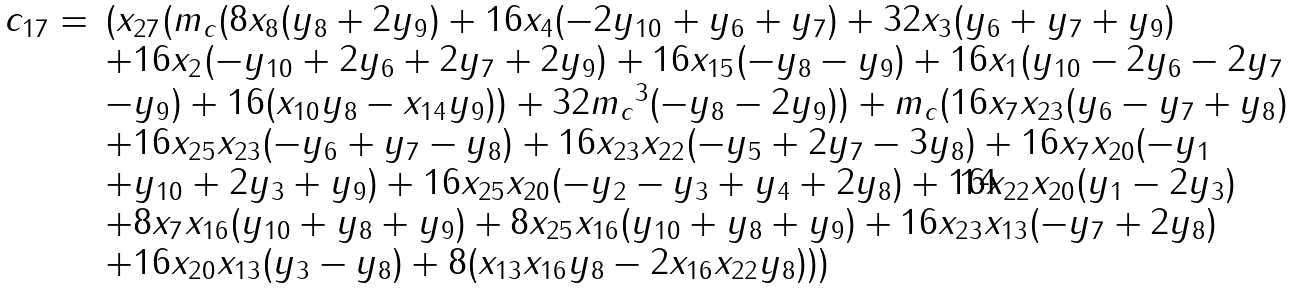Convert formula to latex. <formula><loc_0><loc_0><loc_500><loc_500>\begin{array} { l l } c _ { 1 7 } = & ( x _ { 2 7 } ( { m _ { c } } ( 8 x _ { 8 } ( y _ { 8 } + 2 y _ { 9 } ) + 1 6 x _ { 4 } ( - 2 y _ { 1 0 } + y _ { 6 } + y _ { 7 } ) + 3 2 x _ { 3 } ( y _ { 6 } + y _ { 7 } + y _ { 9 } ) \\ & + 1 6 x _ { 2 } ( - y _ { 1 0 } + 2 y _ { 6 } + 2 y _ { 7 } + 2 y _ { 9 } ) + 1 6 x _ { 1 5 } ( - y _ { 8 } - y _ { 9 } ) + 1 6 x _ { 1 } ( y _ { 1 0 } - 2 y _ { 6 } - 2 y _ { 7 } \\ & - y _ { 9 } ) + 1 6 ( x _ { 1 0 } y _ { 8 } - x _ { 1 4 } y _ { 9 } ) ) + 3 2 { m _ { c } } ^ { 3 } ( - y _ { 8 } - 2 y _ { 9 } ) ) + { m _ { c } } ( 1 6 x _ { 7 } x _ { 2 3 } ( y _ { 6 } - y _ { 7 } + y _ { 8 } ) \\ & + 1 6 x _ { 2 5 } x _ { 2 3 } ( - y _ { 6 } + y _ { 7 } - y _ { 8 } ) + 1 6 x _ { 2 3 } x _ { 2 2 } ( - y _ { 5 } + 2 y _ { 7 } - 3 y _ { 8 } ) + 1 6 x _ { 7 } x _ { 2 0 } ( - y _ { 1 } \\ & + y _ { 1 0 } + 2 y _ { 3 } + y _ { 9 } ) + 1 6 x _ { 2 5 } x _ { 2 0 } ( - y _ { 2 } - y _ { 3 } + y _ { 4 } + 2 y _ { 8 } ) + 1 6 x _ { 2 2 } x _ { 2 0 } ( y _ { 1 } - 2 y _ { 3 } ) \\ & + 8 x _ { 7 } x _ { 1 6 } ( y _ { 1 0 } + y _ { 8 } + y _ { 9 } ) + 8 x _ { 2 5 } x _ { 1 6 } ( y _ { 1 0 } + y _ { 8 } + y _ { 9 } ) + 1 6 x _ { 2 3 } x _ { 1 3 } ( - y _ { 7 } + 2 y _ { 8 } ) \\ & + 1 6 x _ { 2 0 } x _ { 1 3 } ( y _ { 3 } - y _ { 8 } ) + 8 ( x _ { 1 3 } x _ { 1 6 } y _ { 8 } - 2 x _ { 1 6 } x _ { 2 2 } y _ { 8 } ) ) ) \end{array}</formula> 